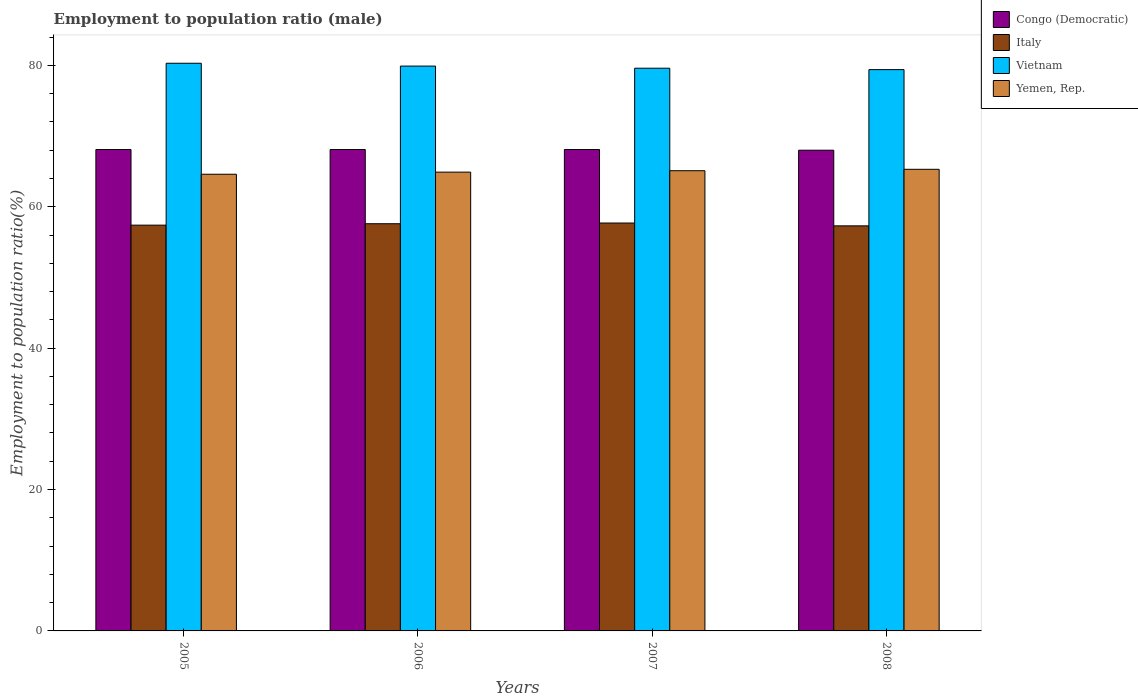How many different coloured bars are there?
Your answer should be very brief. 4. How many bars are there on the 1st tick from the left?
Offer a terse response. 4. What is the employment to population ratio in Yemen, Rep. in 2005?
Give a very brief answer. 64.6. Across all years, what is the maximum employment to population ratio in Vietnam?
Give a very brief answer. 80.3. Across all years, what is the minimum employment to population ratio in Vietnam?
Your answer should be very brief. 79.4. In which year was the employment to population ratio in Vietnam maximum?
Keep it short and to the point. 2005. In which year was the employment to population ratio in Italy minimum?
Keep it short and to the point. 2008. What is the total employment to population ratio in Congo (Democratic) in the graph?
Offer a very short reply. 272.3. What is the difference between the employment to population ratio in Vietnam in 2006 and that in 2007?
Keep it short and to the point. 0.3. What is the difference between the employment to population ratio in Italy in 2007 and the employment to population ratio in Yemen, Rep. in 2006?
Provide a succinct answer. -7.2. What is the average employment to population ratio in Yemen, Rep. per year?
Your response must be concise. 64.98. In the year 2006, what is the difference between the employment to population ratio in Italy and employment to population ratio in Vietnam?
Make the answer very short. -22.3. What is the ratio of the employment to population ratio in Yemen, Rep. in 2005 to that in 2006?
Keep it short and to the point. 1. What is the difference between the highest and the second highest employment to population ratio in Yemen, Rep.?
Provide a short and direct response. 0.2. What is the difference between the highest and the lowest employment to population ratio in Congo (Democratic)?
Your answer should be very brief. 0.1. What does the 3rd bar from the left in 2007 represents?
Keep it short and to the point. Vietnam. What does the 4th bar from the right in 2007 represents?
Offer a terse response. Congo (Democratic). Is it the case that in every year, the sum of the employment to population ratio in Vietnam and employment to population ratio in Congo (Democratic) is greater than the employment to population ratio in Yemen, Rep.?
Make the answer very short. Yes. How many bars are there?
Make the answer very short. 16. What is the difference between two consecutive major ticks on the Y-axis?
Your answer should be very brief. 20. Are the values on the major ticks of Y-axis written in scientific E-notation?
Your answer should be very brief. No. Does the graph contain grids?
Offer a very short reply. No. Where does the legend appear in the graph?
Your answer should be very brief. Top right. How many legend labels are there?
Offer a very short reply. 4. What is the title of the graph?
Keep it short and to the point. Employment to population ratio (male). What is the label or title of the Y-axis?
Your response must be concise. Employment to population ratio(%). What is the Employment to population ratio(%) in Congo (Democratic) in 2005?
Offer a very short reply. 68.1. What is the Employment to population ratio(%) in Italy in 2005?
Give a very brief answer. 57.4. What is the Employment to population ratio(%) in Vietnam in 2005?
Make the answer very short. 80.3. What is the Employment to population ratio(%) in Yemen, Rep. in 2005?
Offer a terse response. 64.6. What is the Employment to population ratio(%) of Congo (Democratic) in 2006?
Your response must be concise. 68.1. What is the Employment to population ratio(%) in Italy in 2006?
Provide a succinct answer. 57.6. What is the Employment to population ratio(%) in Vietnam in 2006?
Your answer should be compact. 79.9. What is the Employment to population ratio(%) in Yemen, Rep. in 2006?
Give a very brief answer. 64.9. What is the Employment to population ratio(%) of Congo (Democratic) in 2007?
Give a very brief answer. 68.1. What is the Employment to population ratio(%) in Italy in 2007?
Offer a terse response. 57.7. What is the Employment to population ratio(%) of Vietnam in 2007?
Give a very brief answer. 79.6. What is the Employment to population ratio(%) of Yemen, Rep. in 2007?
Offer a terse response. 65.1. What is the Employment to population ratio(%) in Congo (Democratic) in 2008?
Provide a succinct answer. 68. What is the Employment to population ratio(%) in Italy in 2008?
Offer a terse response. 57.3. What is the Employment to population ratio(%) in Vietnam in 2008?
Give a very brief answer. 79.4. What is the Employment to population ratio(%) in Yemen, Rep. in 2008?
Offer a very short reply. 65.3. Across all years, what is the maximum Employment to population ratio(%) in Congo (Democratic)?
Offer a very short reply. 68.1. Across all years, what is the maximum Employment to population ratio(%) of Italy?
Offer a very short reply. 57.7. Across all years, what is the maximum Employment to population ratio(%) in Vietnam?
Your answer should be very brief. 80.3. Across all years, what is the maximum Employment to population ratio(%) of Yemen, Rep.?
Your answer should be very brief. 65.3. Across all years, what is the minimum Employment to population ratio(%) of Italy?
Your answer should be compact. 57.3. Across all years, what is the minimum Employment to population ratio(%) in Vietnam?
Make the answer very short. 79.4. Across all years, what is the minimum Employment to population ratio(%) of Yemen, Rep.?
Make the answer very short. 64.6. What is the total Employment to population ratio(%) in Congo (Democratic) in the graph?
Your answer should be compact. 272.3. What is the total Employment to population ratio(%) in Italy in the graph?
Make the answer very short. 230. What is the total Employment to population ratio(%) of Vietnam in the graph?
Provide a short and direct response. 319.2. What is the total Employment to population ratio(%) of Yemen, Rep. in the graph?
Provide a short and direct response. 259.9. What is the difference between the Employment to population ratio(%) in Congo (Democratic) in 2005 and that in 2006?
Your response must be concise. 0. What is the difference between the Employment to population ratio(%) of Italy in 2005 and that in 2006?
Provide a succinct answer. -0.2. What is the difference between the Employment to population ratio(%) in Vietnam in 2005 and that in 2006?
Your answer should be very brief. 0.4. What is the difference between the Employment to population ratio(%) of Yemen, Rep. in 2005 and that in 2006?
Your answer should be compact. -0.3. What is the difference between the Employment to population ratio(%) of Congo (Democratic) in 2005 and that in 2007?
Your response must be concise. 0. What is the difference between the Employment to population ratio(%) in Italy in 2005 and that in 2007?
Ensure brevity in your answer.  -0.3. What is the difference between the Employment to population ratio(%) in Vietnam in 2005 and that in 2007?
Offer a very short reply. 0.7. What is the difference between the Employment to population ratio(%) of Yemen, Rep. in 2005 and that in 2007?
Keep it short and to the point. -0.5. What is the difference between the Employment to population ratio(%) of Congo (Democratic) in 2005 and that in 2008?
Keep it short and to the point. 0.1. What is the difference between the Employment to population ratio(%) of Italy in 2005 and that in 2008?
Your answer should be very brief. 0.1. What is the difference between the Employment to population ratio(%) in Vietnam in 2005 and that in 2008?
Provide a short and direct response. 0.9. What is the difference between the Employment to population ratio(%) of Vietnam in 2006 and that in 2007?
Ensure brevity in your answer.  0.3. What is the difference between the Employment to population ratio(%) of Italy in 2006 and that in 2008?
Give a very brief answer. 0.3. What is the difference between the Employment to population ratio(%) of Vietnam in 2006 and that in 2008?
Offer a terse response. 0.5. What is the difference between the Employment to population ratio(%) in Yemen, Rep. in 2006 and that in 2008?
Ensure brevity in your answer.  -0.4. What is the difference between the Employment to population ratio(%) in Congo (Democratic) in 2007 and that in 2008?
Your answer should be compact. 0.1. What is the difference between the Employment to population ratio(%) of Italy in 2007 and that in 2008?
Keep it short and to the point. 0.4. What is the difference between the Employment to population ratio(%) of Congo (Democratic) in 2005 and the Employment to population ratio(%) of Italy in 2006?
Offer a terse response. 10.5. What is the difference between the Employment to population ratio(%) of Congo (Democratic) in 2005 and the Employment to population ratio(%) of Vietnam in 2006?
Provide a succinct answer. -11.8. What is the difference between the Employment to population ratio(%) in Congo (Democratic) in 2005 and the Employment to population ratio(%) in Yemen, Rep. in 2006?
Your answer should be compact. 3.2. What is the difference between the Employment to population ratio(%) in Italy in 2005 and the Employment to population ratio(%) in Vietnam in 2006?
Give a very brief answer. -22.5. What is the difference between the Employment to population ratio(%) in Vietnam in 2005 and the Employment to population ratio(%) in Yemen, Rep. in 2006?
Your answer should be very brief. 15.4. What is the difference between the Employment to population ratio(%) of Congo (Democratic) in 2005 and the Employment to population ratio(%) of Italy in 2007?
Provide a short and direct response. 10.4. What is the difference between the Employment to population ratio(%) in Congo (Democratic) in 2005 and the Employment to population ratio(%) in Yemen, Rep. in 2007?
Keep it short and to the point. 3. What is the difference between the Employment to population ratio(%) in Italy in 2005 and the Employment to population ratio(%) in Vietnam in 2007?
Give a very brief answer. -22.2. What is the difference between the Employment to population ratio(%) of Italy in 2005 and the Employment to population ratio(%) of Yemen, Rep. in 2007?
Provide a succinct answer. -7.7. What is the difference between the Employment to population ratio(%) of Italy in 2005 and the Employment to population ratio(%) of Yemen, Rep. in 2008?
Your answer should be compact. -7.9. What is the difference between the Employment to population ratio(%) of Vietnam in 2005 and the Employment to population ratio(%) of Yemen, Rep. in 2008?
Offer a terse response. 15. What is the difference between the Employment to population ratio(%) in Congo (Democratic) in 2006 and the Employment to population ratio(%) in Yemen, Rep. in 2007?
Offer a very short reply. 3. What is the difference between the Employment to population ratio(%) in Congo (Democratic) in 2006 and the Employment to population ratio(%) in Italy in 2008?
Make the answer very short. 10.8. What is the difference between the Employment to population ratio(%) of Congo (Democratic) in 2006 and the Employment to population ratio(%) of Yemen, Rep. in 2008?
Your answer should be compact. 2.8. What is the difference between the Employment to population ratio(%) of Italy in 2006 and the Employment to population ratio(%) of Vietnam in 2008?
Provide a short and direct response. -21.8. What is the difference between the Employment to population ratio(%) in Italy in 2006 and the Employment to population ratio(%) in Yemen, Rep. in 2008?
Your response must be concise. -7.7. What is the difference between the Employment to population ratio(%) in Congo (Democratic) in 2007 and the Employment to population ratio(%) in Vietnam in 2008?
Provide a succinct answer. -11.3. What is the difference between the Employment to population ratio(%) of Italy in 2007 and the Employment to population ratio(%) of Vietnam in 2008?
Offer a very short reply. -21.7. What is the difference between the Employment to population ratio(%) in Italy in 2007 and the Employment to population ratio(%) in Yemen, Rep. in 2008?
Offer a terse response. -7.6. What is the average Employment to population ratio(%) of Congo (Democratic) per year?
Ensure brevity in your answer.  68.08. What is the average Employment to population ratio(%) of Italy per year?
Provide a short and direct response. 57.5. What is the average Employment to population ratio(%) in Vietnam per year?
Offer a terse response. 79.8. What is the average Employment to population ratio(%) of Yemen, Rep. per year?
Provide a short and direct response. 64.97. In the year 2005, what is the difference between the Employment to population ratio(%) in Congo (Democratic) and Employment to population ratio(%) in Yemen, Rep.?
Your answer should be very brief. 3.5. In the year 2005, what is the difference between the Employment to population ratio(%) of Italy and Employment to population ratio(%) of Vietnam?
Provide a short and direct response. -22.9. In the year 2005, what is the difference between the Employment to population ratio(%) in Italy and Employment to population ratio(%) in Yemen, Rep.?
Keep it short and to the point. -7.2. In the year 2005, what is the difference between the Employment to population ratio(%) in Vietnam and Employment to population ratio(%) in Yemen, Rep.?
Your answer should be very brief. 15.7. In the year 2006, what is the difference between the Employment to population ratio(%) of Congo (Democratic) and Employment to population ratio(%) of Vietnam?
Give a very brief answer. -11.8. In the year 2006, what is the difference between the Employment to population ratio(%) of Congo (Democratic) and Employment to population ratio(%) of Yemen, Rep.?
Make the answer very short. 3.2. In the year 2006, what is the difference between the Employment to population ratio(%) of Italy and Employment to population ratio(%) of Vietnam?
Provide a succinct answer. -22.3. In the year 2006, what is the difference between the Employment to population ratio(%) in Vietnam and Employment to population ratio(%) in Yemen, Rep.?
Give a very brief answer. 15. In the year 2007, what is the difference between the Employment to population ratio(%) of Congo (Democratic) and Employment to population ratio(%) of Vietnam?
Offer a terse response. -11.5. In the year 2007, what is the difference between the Employment to population ratio(%) in Congo (Democratic) and Employment to population ratio(%) in Yemen, Rep.?
Ensure brevity in your answer.  3. In the year 2007, what is the difference between the Employment to population ratio(%) of Italy and Employment to population ratio(%) of Vietnam?
Offer a very short reply. -21.9. In the year 2008, what is the difference between the Employment to population ratio(%) in Congo (Democratic) and Employment to population ratio(%) in Yemen, Rep.?
Offer a terse response. 2.7. In the year 2008, what is the difference between the Employment to population ratio(%) in Italy and Employment to population ratio(%) in Vietnam?
Provide a succinct answer. -22.1. In the year 2008, what is the difference between the Employment to population ratio(%) in Italy and Employment to population ratio(%) in Yemen, Rep.?
Your answer should be compact. -8. What is the ratio of the Employment to population ratio(%) in Italy in 2005 to that in 2006?
Offer a terse response. 1. What is the ratio of the Employment to population ratio(%) of Vietnam in 2005 to that in 2006?
Offer a very short reply. 1. What is the ratio of the Employment to population ratio(%) of Yemen, Rep. in 2005 to that in 2006?
Keep it short and to the point. 1. What is the ratio of the Employment to population ratio(%) of Italy in 2005 to that in 2007?
Offer a terse response. 0.99. What is the ratio of the Employment to population ratio(%) of Vietnam in 2005 to that in 2007?
Keep it short and to the point. 1.01. What is the ratio of the Employment to population ratio(%) of Yemen, Rep. in 2005 to that in 2007?
Your answer should be compact. 0.99. What is the ratio of the Employment to population ratio(%) in Vietnam in 2005 to that in 2008?
Keep it short and to the point. 1.01. What is the ratio of the Employment to population ratio(%) of Yemen, Rep. in 2005 to that in 2008?
Make the answer very short. 0.99. What is the ratio of the Employment to population ratio(%) in Congo (Democratic) in 2006 to that in 2007?
Your answer should be very brief. 1. What is the ratio of the Employment to population ratio(%) of Italy in 2006 to that in 2007?
Your response must be concise. 1. What is the ratio of the Employment to population ratio(%) in Vietnam in 2006 to that in 2007?
Provide a short and direct response. 1. What is the ratio of the Employment to population ratio(%) of Vietnam in 2006 to that in 2008?
Make the answer very short. 1.01. What is the ratio of the Employment to population ratio(%) of Yemen, Rep. in 2006 to that in 2008?
Offer a terse response. 0.99. What is the ratio of the Employment to population ratio(%) of Italy in 2007 to that in 2008?
Offer a very short reply. 1.01. What is the difference between the highest and the second highest Employment to population ratio(%) of Congo (Democratic)?
Make the answer very short. 0. What is the difference between the highest and the second highest Employment to population ratio(%) in Italy?
Ensure brevity in your answer.  0.1. What is the difference between the highest and the second highest Employment to population ratio(%) in Vietnam?
Keep it short and to the point. 0.4. What is the difference between the highest and the second highest Employment to population ratio(%) of Yemen, Rep.?
Offer a very short reply. 0.2. What is the difference between the highest and the lowest Employment to population ratio(%) in Italy?
Provide a short and direct response. 0.4. What is the difference between the highest and the lowest Employment to population ratio(%) of Yemen, Rep.?
Offer a terse response. 0.7. 